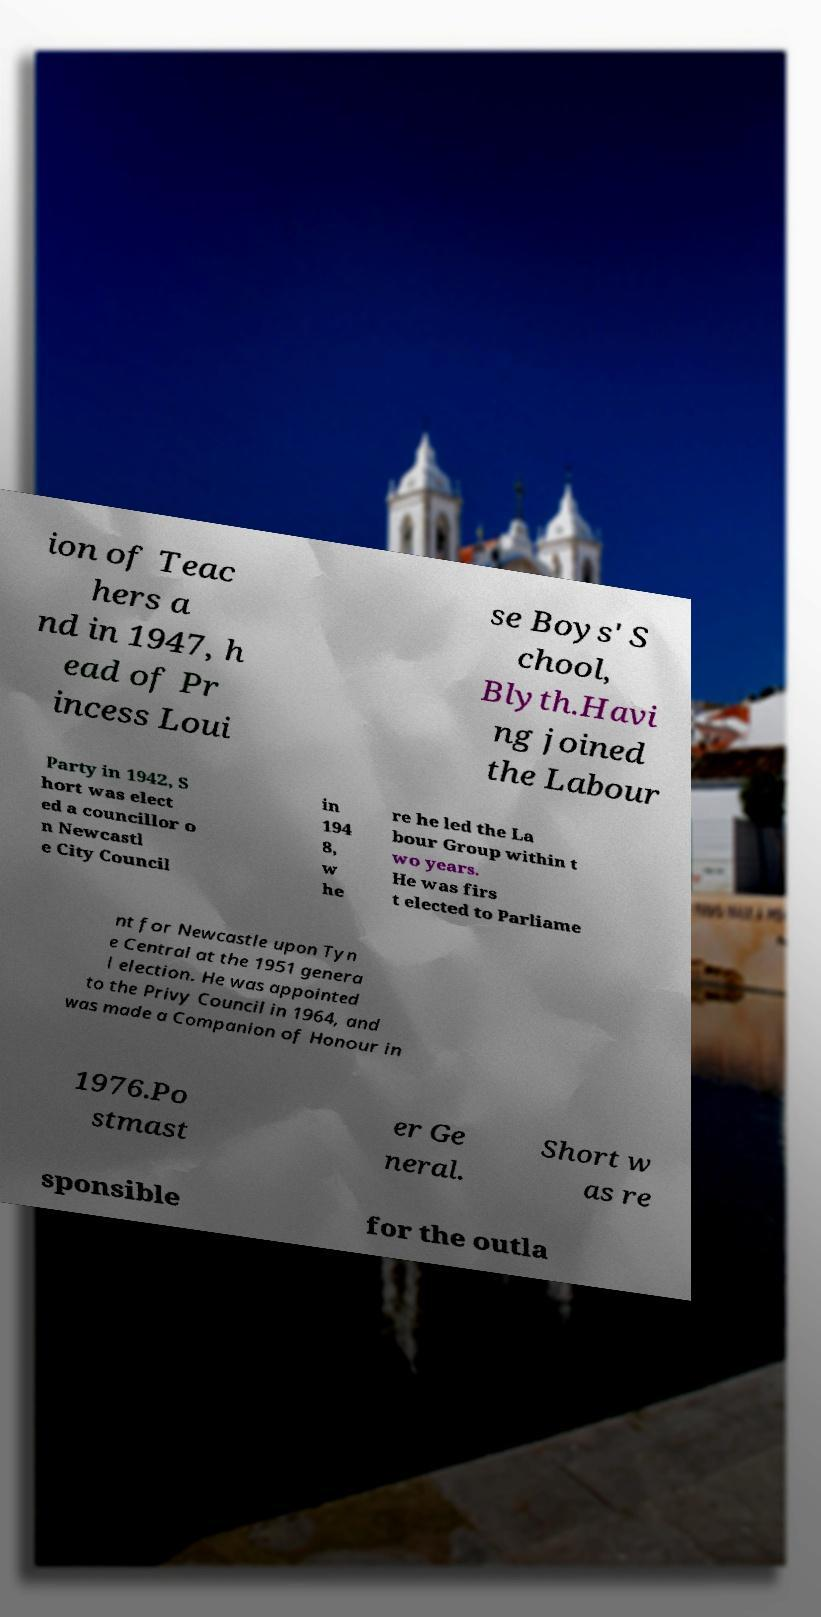Please identify and transcribe the text found in this image. ion of Teac hers a nd in 1947, h ead of Pr incess Loui se Boys' S chool, Blyth.Havi ng joined the Labour Party in 1942, S hort was elect ed a councillor o n Newcastl e City Council in 194 8, w he re he led the La bour Group within t wo years. He was firs t elected to Parliame nt for Newcastle upon Tyn e Central at the 1951 genera l election. He was appointed to the Privy Council in 1964, and was made a Companion of Honour in 1976.Po stmast er Ge neral. Short w as re sponsible for the outla 